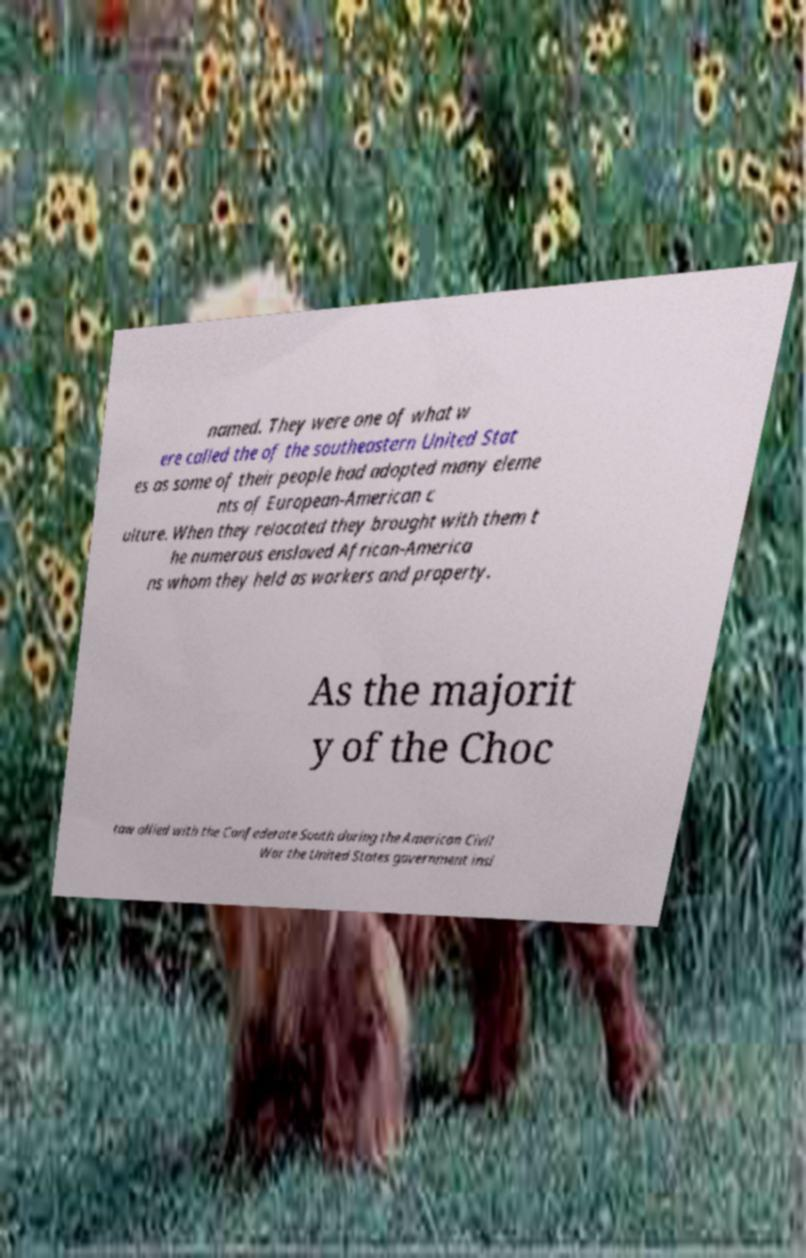Could you assist in decoding the text presented in this image and type it out clearly? named. They were one of what w ere called the of the southeastern United Stat es as some of their people had adopted many eleme nts of European-American c ulture. When they relocated they brought with them t he numerous enslaved African-America ns whom they held as workers and property. As the majorit y of the Choc taw allied with the Confederate South during the American Civil War the United States government insi 